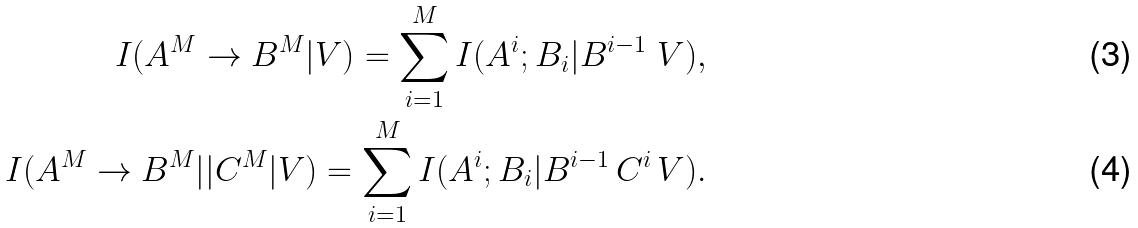Convert formula to latex. <formula><loc_0><loc_0><loc_500><loc_500>I ( A ^ { M } \to B ^ { M } | V ) = \sum _ { i = 1 } ^ { M } I ( A ^ { i } ; B _ { i } | B ^ { i - 1 } \ V ) , \\ I ( A ^ { M } \to B ^ { M } | | C ^ { M } | V ) = \sum _ { i = 1 } ^ { M } I ( A ^ { i } ; B _ { i } | B ^ { i - 1 } \, C ^ { i } \, V ) .</formula> 